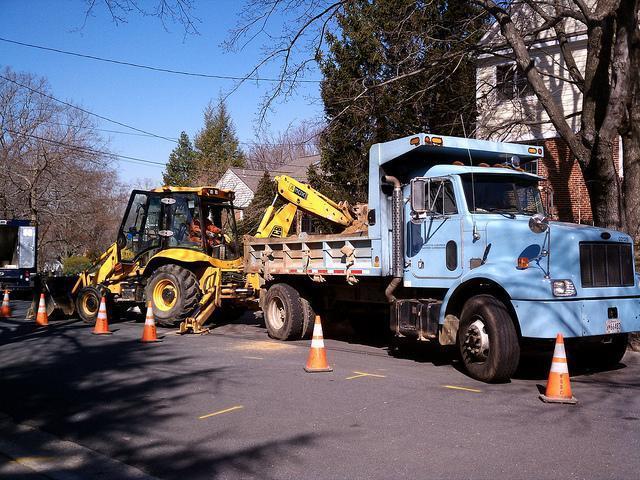How many trucks are there?
Give a very brief answer. 2. 